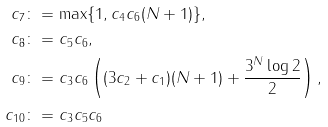Convert formula to latex. <formula><loc_0><loc_0><loc_500><loc_500>c _ { 7 } & \colon = \max \{ 1 , c _ { 4 } c _ { 6 } ( N + 1 ) \} , \\ c _ { 8 } & \colon = c _ { 5 } c _ { 6 } , \\ c _ { 9 } & \colon = c _ { 3 } c _ { 6 } \left ( ( 3 c _ { 2 } + c _ { 1 } ) ( N + 1 ) + \frac { 3 ^ { N } \log 2 } { 2 } \right ) , \\ c _ { 1 0 } & \colon = c _ { 3 } c _ { 5 } c _ { 6 }</formula> 